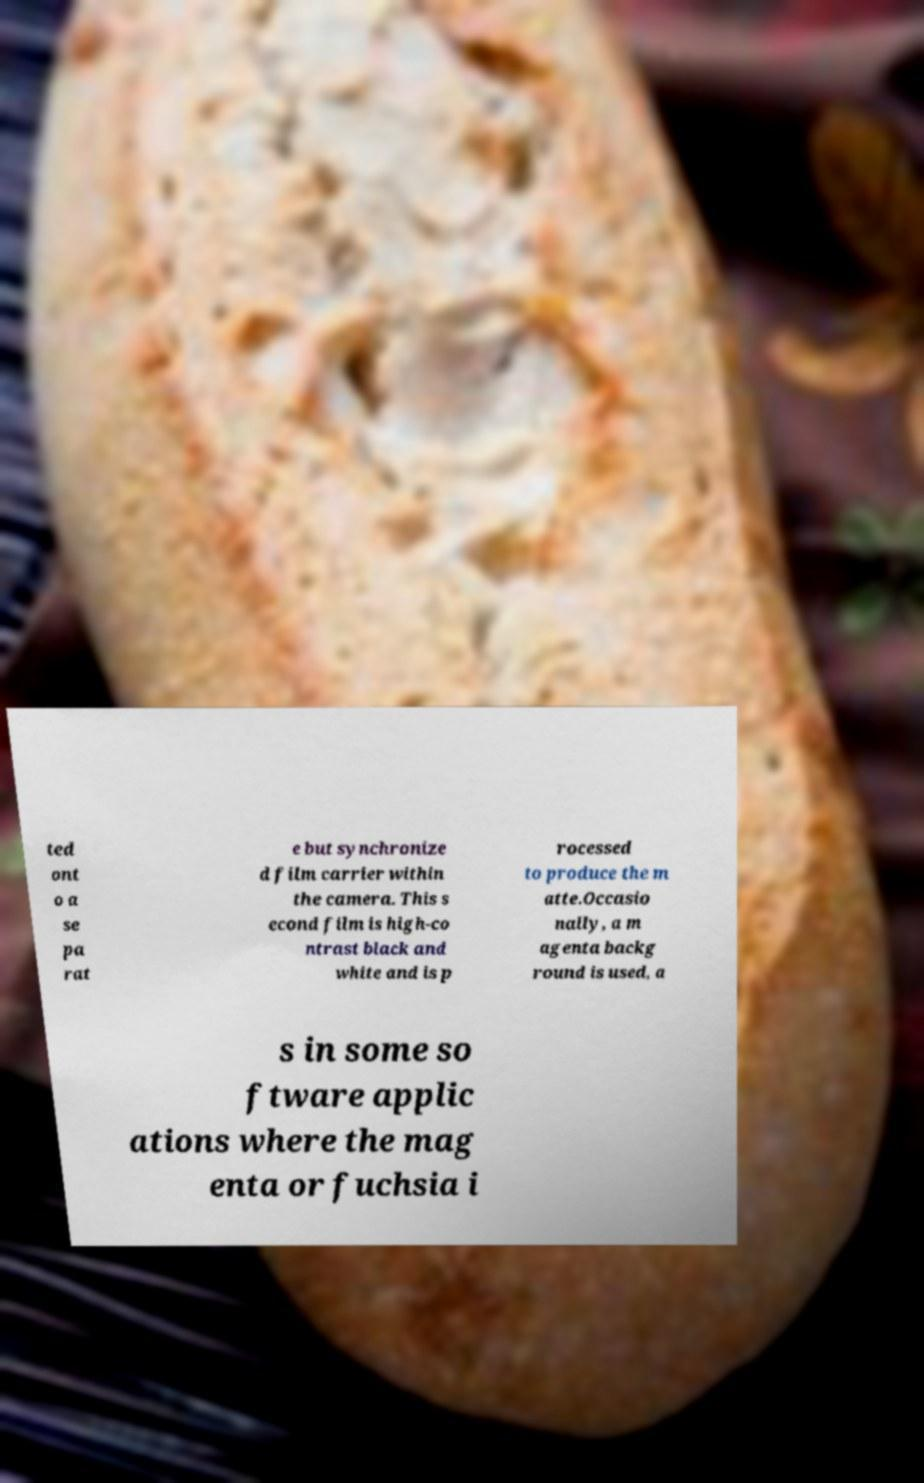Can you accurately transcribe the text from the provided image for me? ted ont o a se pa rat e but synchronize d film carrier within the camera. This s econd film is high-co ntrast black and white and is p rocessed to produce the m atte.Occasio nally, a m agenta backg round is used, a s in some so ftware applic ations where the mag enta or fuchsia i 